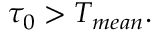Convert formula to latex. <formula><loc_0><loc_0><loc_500><loc_500>\tau _ { 0 } > T _ { m e a n } .</formula> 